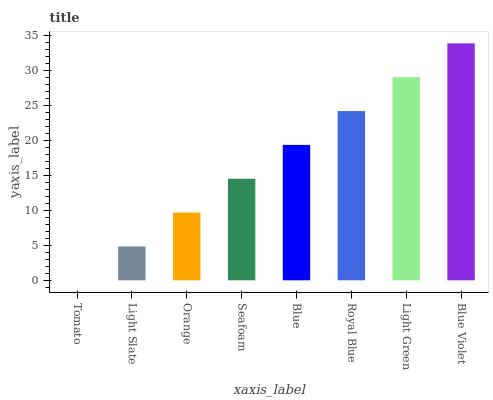Is Tomato the minimum?
Answer yes or no. Yes. Is Blue Violet the maximum?
Answer yes or no. Yes. Is Light Slate the minimum?
Answer yes or no. No. Is Light Slate the maximum?
Answer yes or no. No. Is Light Slate greater than Tomato?
Answer yes or no. Yes. Is Tomato less than Light Slate?
Answer yes or no. Yes. Is Tomato greater than Light Slate?
Answer yes or no. No. Is Light Slate less than Tomato?
Answer yes or no. No. Is Blue the high median?
Answer yes or no. Yes. Is Seafoam the low median?
Answer yes or no. Yes. Is Light Green the high median?
Answer yes or no. No. Is Light Slate the low median?
Answer yes or no. No. 